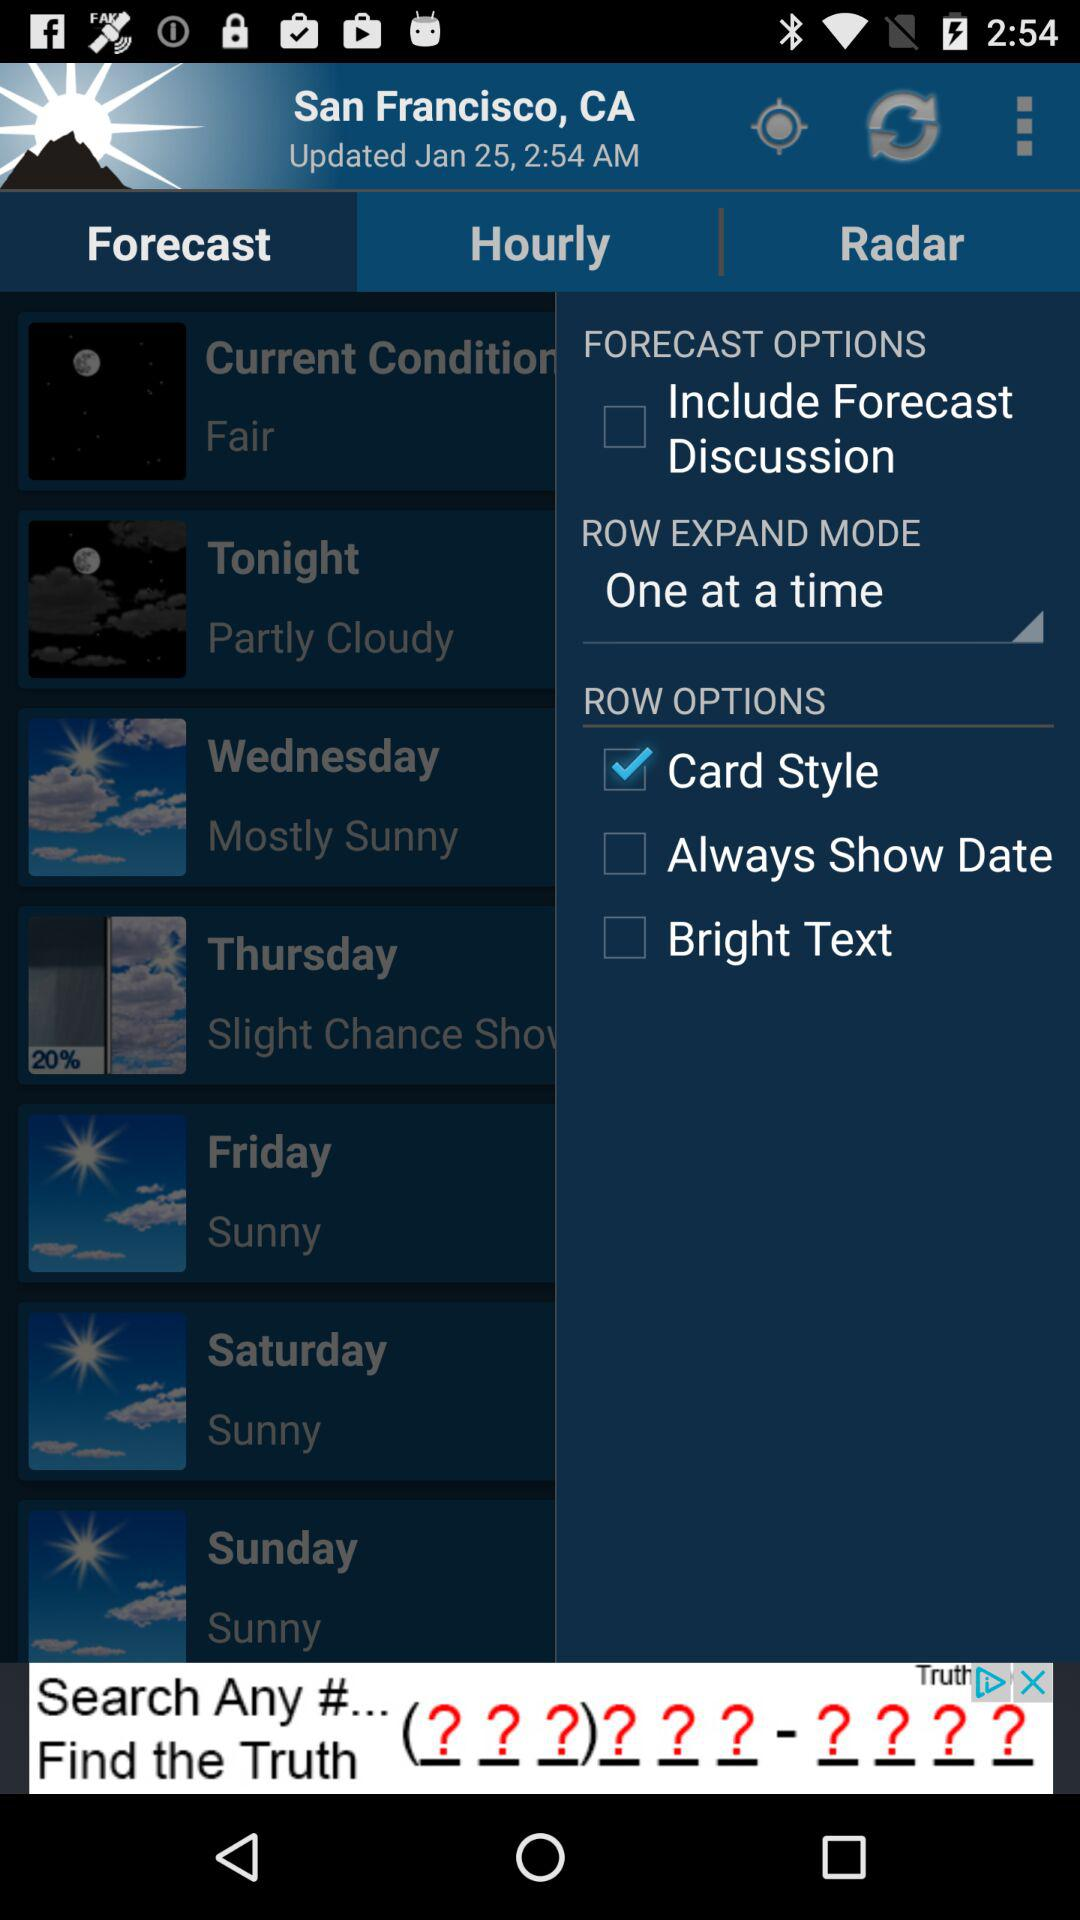What is the updated date? The updated date is January 25. 